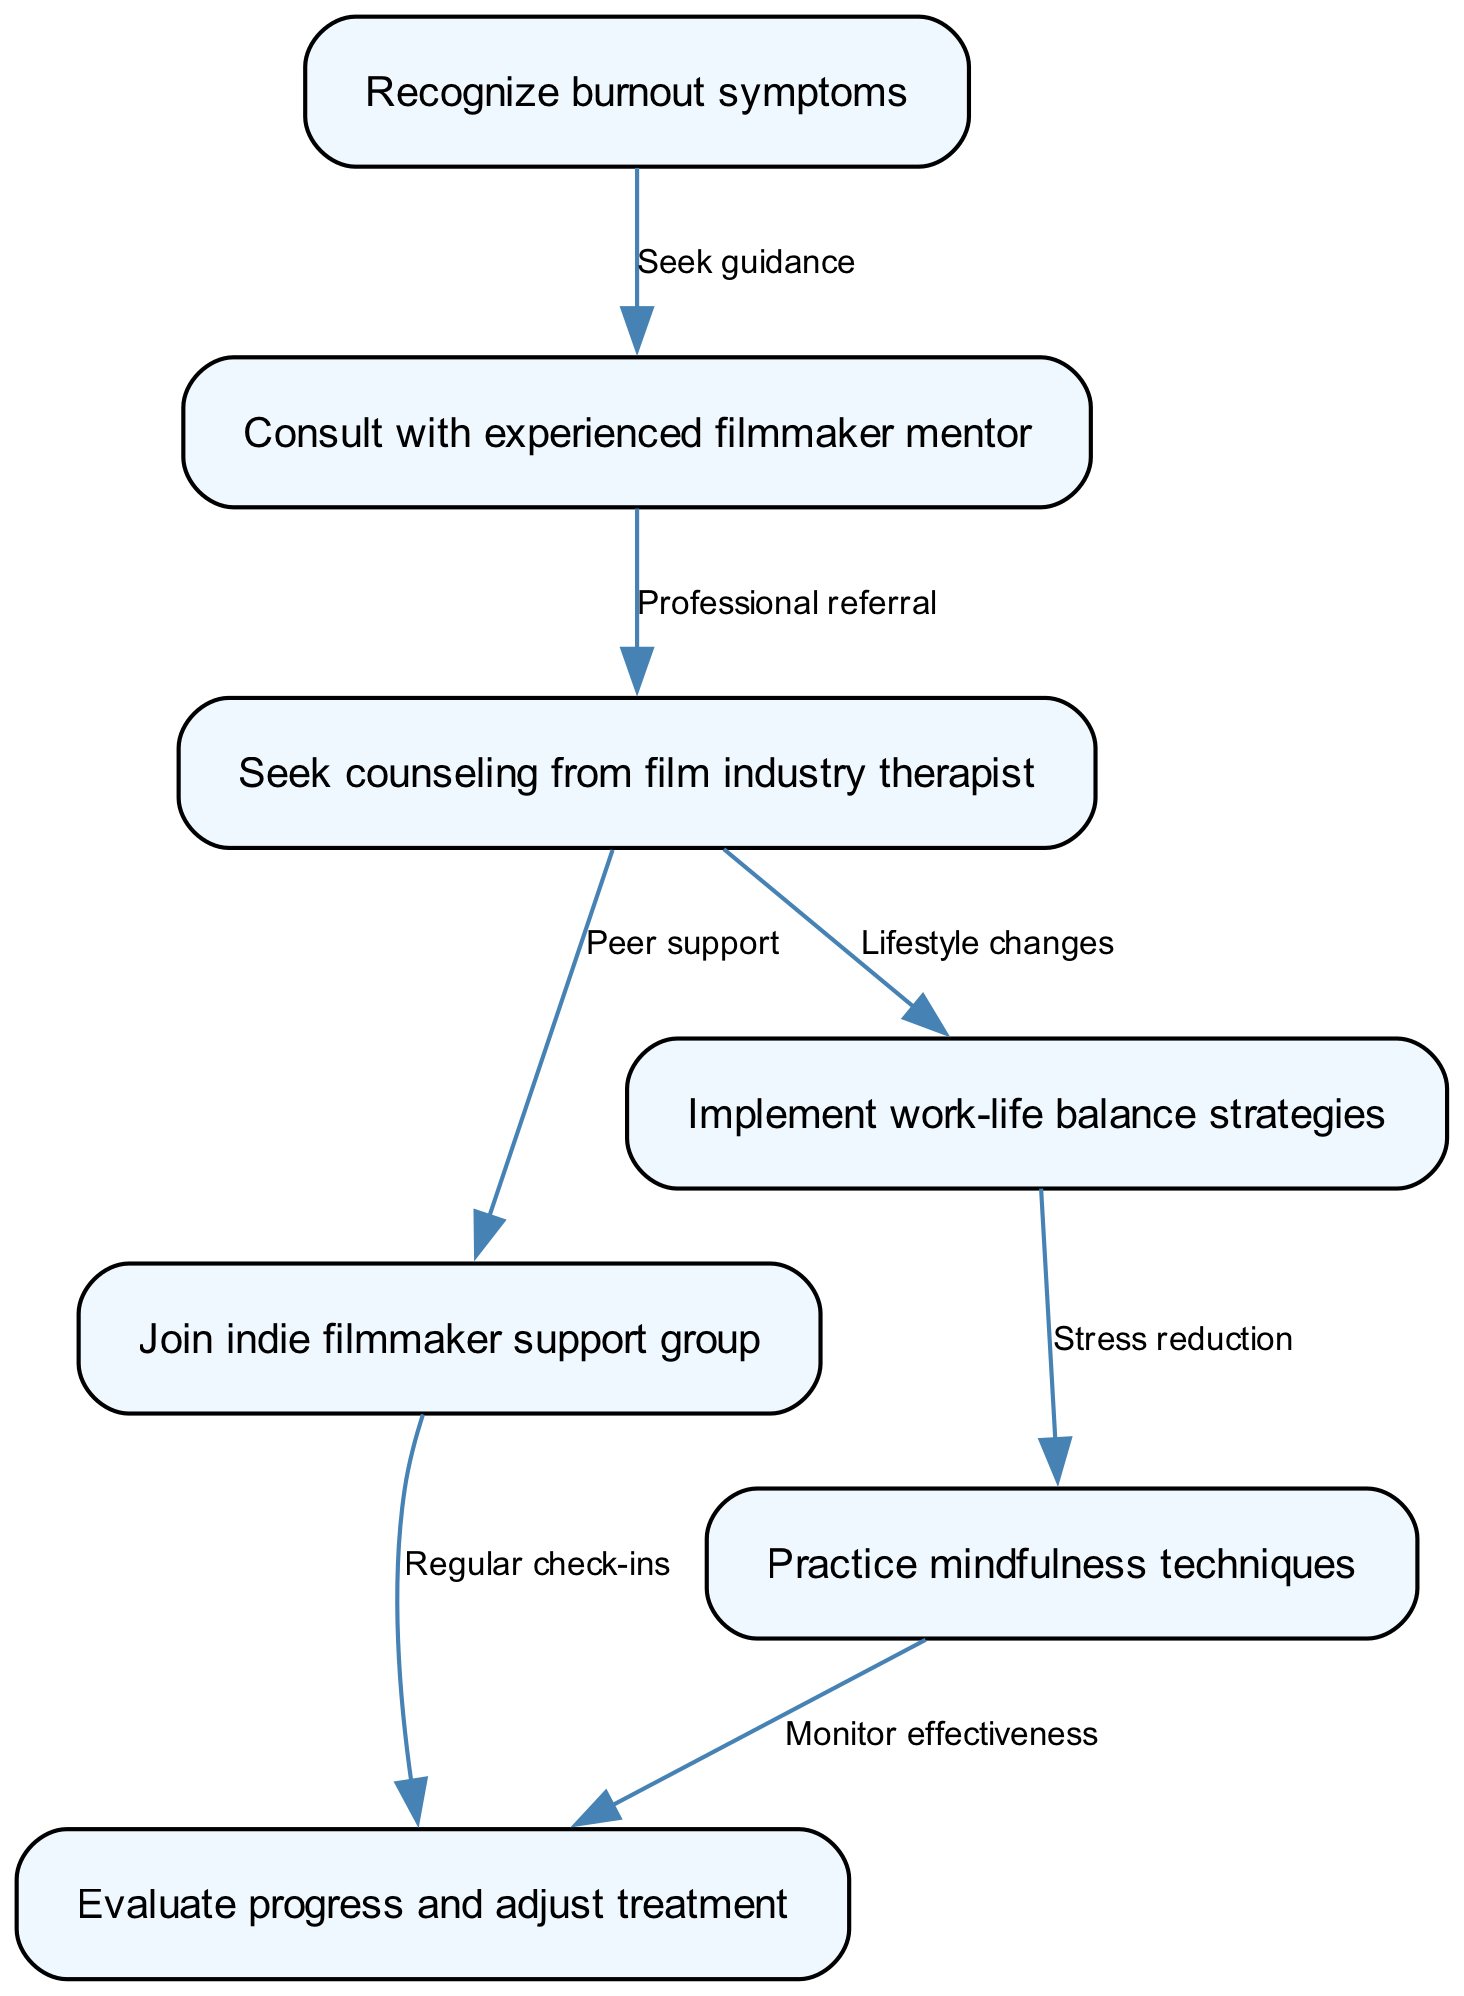What is the first step in the pathway? The first step shown in the diagram is "Recognize burnout symptoms," which is represented as the initial node in the clinical pathway.
Answer: Recognize burnout symptoms How many nodes are there in the diagram? By counting the nodes listed in the data, there are a total of 7 nodes represented in the diagram.
Answer: 7 What follows after consulting with an experienced filmmaker mentor? Following the "Consult with experienced filmmaker mentor" node, the next step is "Seek counseling from film industry therapist," which forms a direct connection.
Answer: Seek counseling from film industry therapist What is the connection between seeking counseling and joining a support group? The connection is that after seeking counseling from a film industry therapist, one should also "Join indie filmmaker support group," as indicated by the edge linking these two nodes.
Answer: Peer support How does stress reduction relate to work-life balance strategies? Stress reduction is part of implementing work-life balance strategies, as indicated by the edge labeled "Stress reduction," establishing a link between these two important strategies in the pathway.
Answer: Lifestyle changes What is evaluated after joining the indie filmmaker support group? After joining the indie filmmaker support group, the next step involves "Evaluate progress and adjust treatment," indicating an ongoing process of assessment and adjustment based on peer interactions.
Answer: Evaluate progress and adjust treatment Which node leads to regular check-ins? The node "Join indie filmmaker support group" leads to "Evaluate progress and adjust treatment," emphasized by a directed edge showing the connection for regular check-ins as part of the support and evaluation process.
Answer: Regular check-ins 